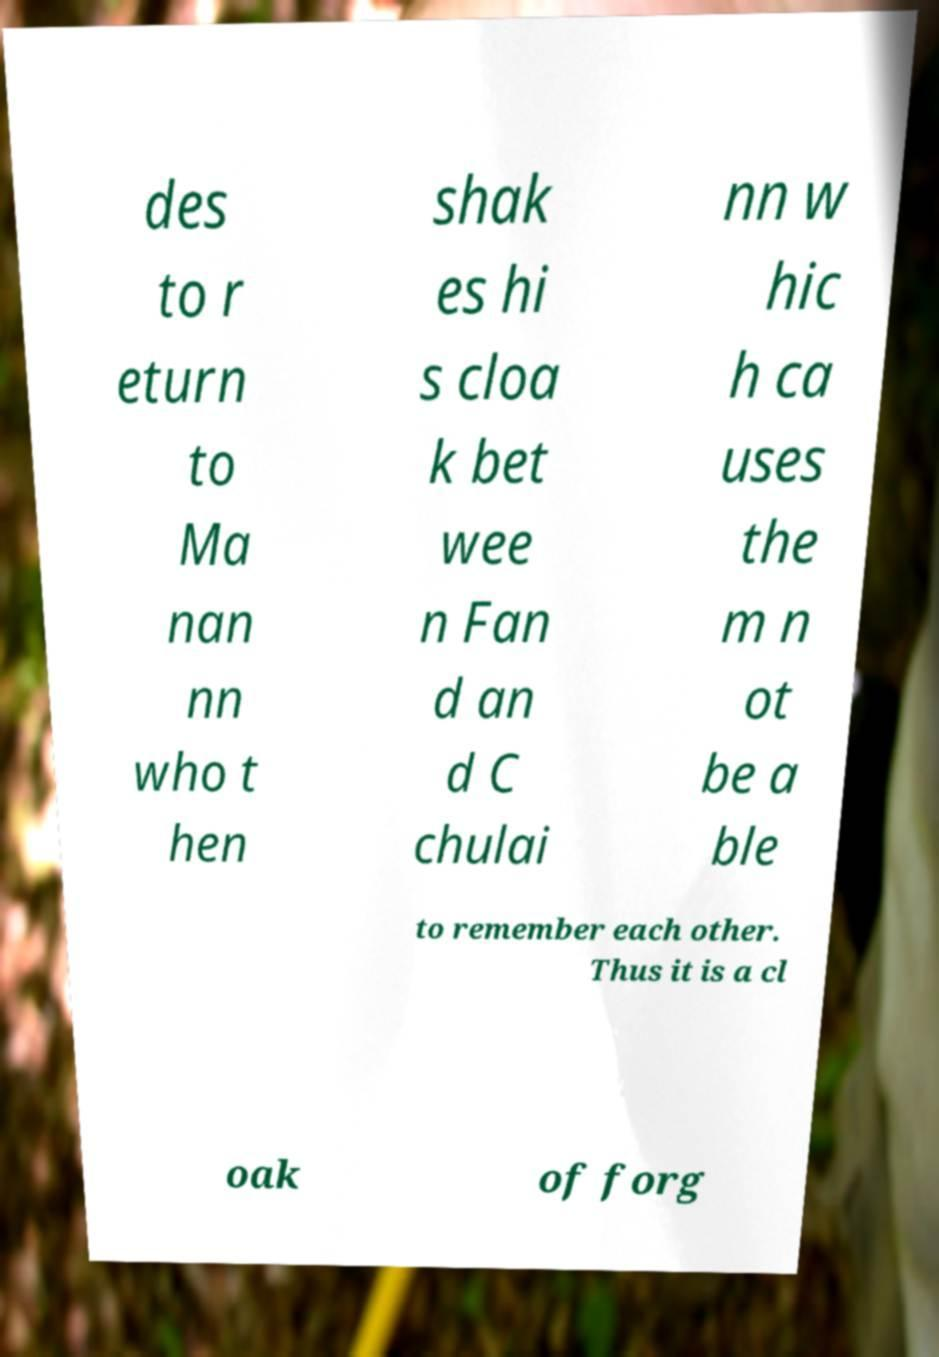Could you extract and type out the text from this image? des to r eturn to Ma nan nn who t hen shak es hi s cloa k bet wee n Fan d an d C chulai nn w hic h ca uses the m n ot be a ble to remember each other. Thus it is a cl oak of forg 